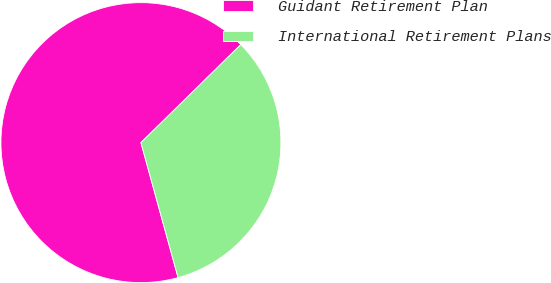<chart> <loc_0><loc_0><loc_500><loc_500><pie_chart><fcel>Guidant Retirement Plan<fcel>International Retirement Plans<nl><fcel>66.92%<fcel>33.08%<nl></chart> 